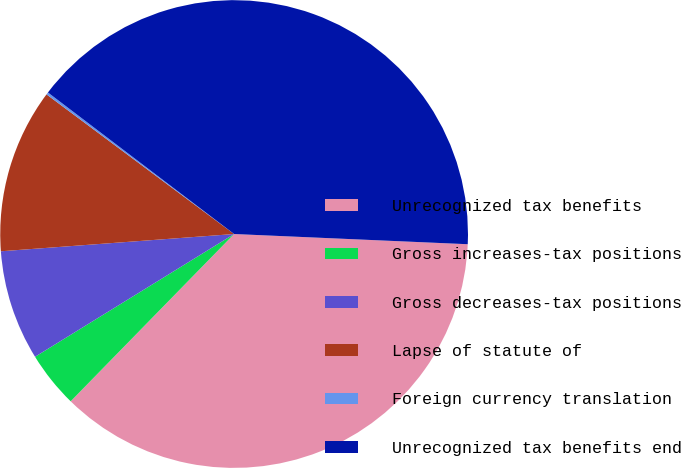Convert chart to OTSL. <chart><loc_0><loc_0><loc_500><loc_500><pie_chart><fcel>Unrecognized tax benefits<fcel>Gross increases-tax positions<fcel>Gross decreases-tax positions<fcel>Lapse of statute of<fcel>Foreign currency translation<fcel>Unrecognized tax benefits end<nl><fcel>36.62%<fcel>3.89%<fcel>7.62%<fcel>11.36%<fcel>0.16%<fcel>40.35%<nl></chart> 